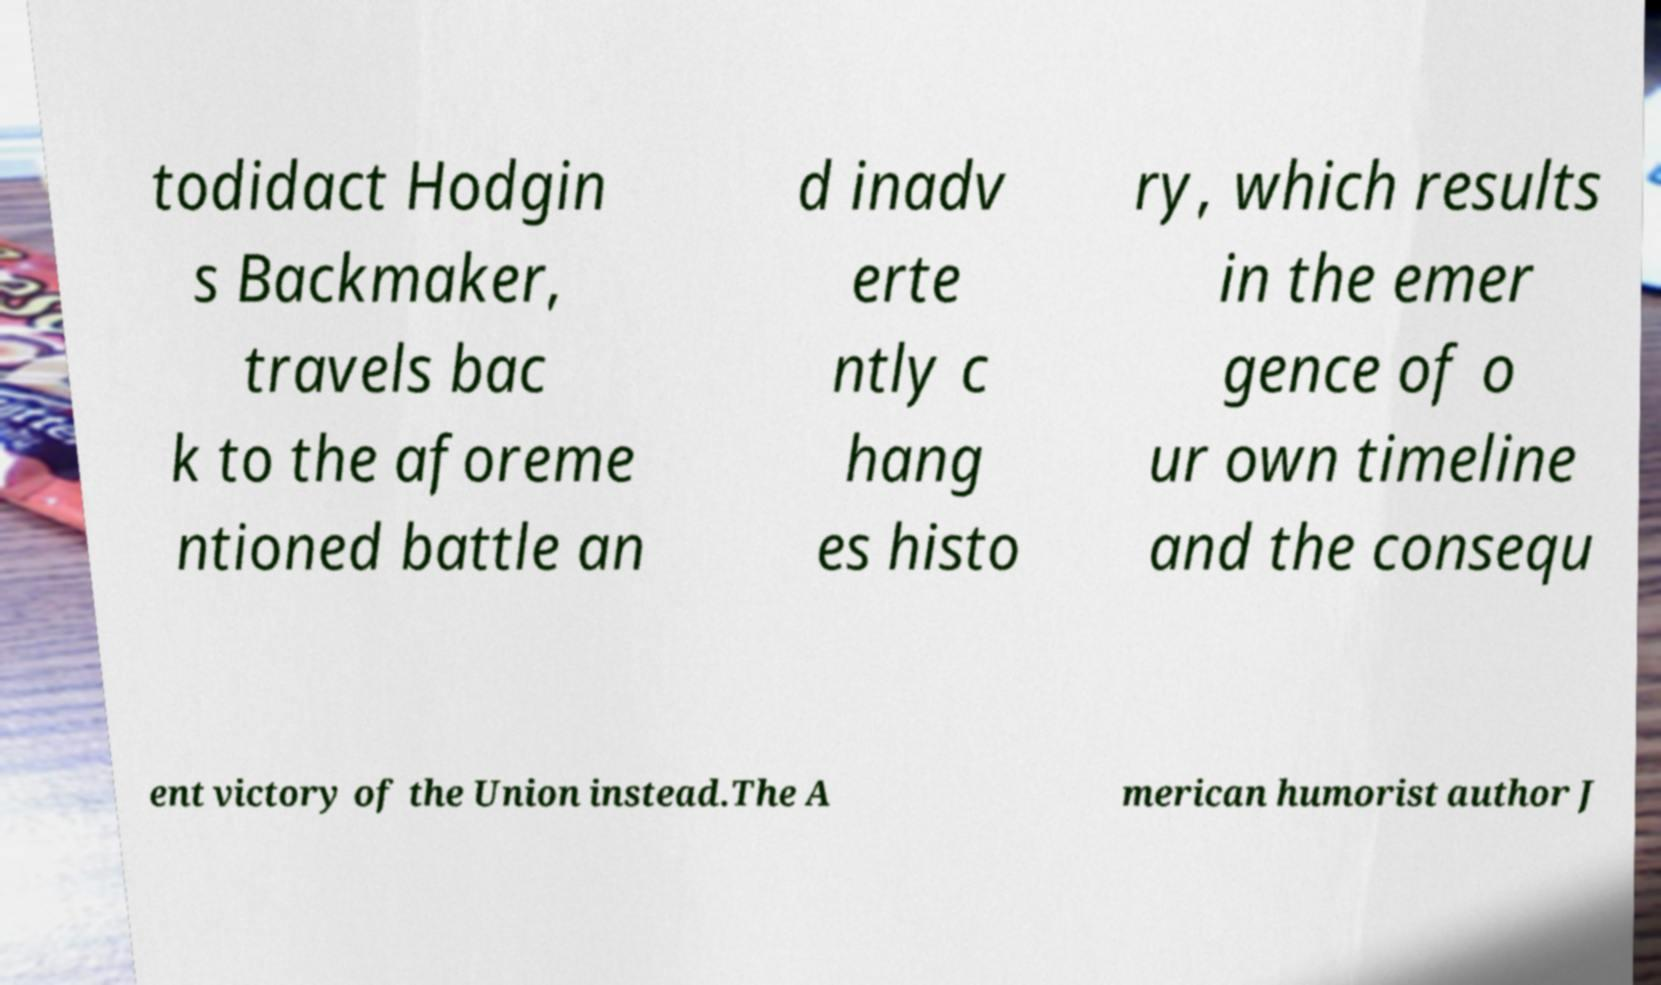What messages or text are displayed in this image? I need them in a readable, typed format. todidact Hodgin s Backmaker, travels bac k to the aforeme ntioned battle an d inadv erte ntly c hang es histo ry, which results in the emer gence of o ur own timeline and the consequ ent victory of the Union instead.The A merican humorist author J 